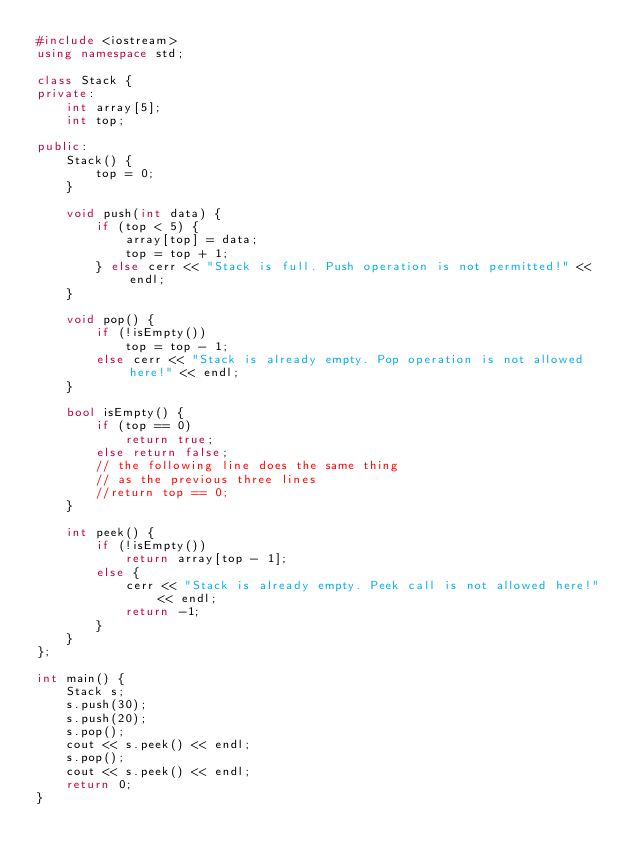<code> <loc_0><loc_0><loc_500><loc_500><_C++_>#include <iostream>
using namespace std;

class Stack {
private:
    int array[5];
    int top;

public:
    Stack() {
        top = 0;
    }

    void push(int data) {
        if (top < 5) {
            array[top] = data;
            top = top + 1;
        } else cerr << "Stack is full. Push operation is not permitted!" << endl;
    }

    void pop() {
        if (!isEmpty())
            top = top - 1;
        else cerr << "Stack is already empty. Pop operation is not allowed here!" << endl;
    }

    bool isEmpty() {
        if (top == 0)
            return true;
        else return false;
        // the following line does the same thing
        // as the previous three lines
        //return top == 0;
    }

    int peek() {
        if (!isEmpty())
            return array[top - 1];
        else {
            cerr << "Stack is already empty. Peek call is not allowed here!" << endl;
            return -1;
        }
    }
};

int main() {
    Stack s;
    s.push(30);
    s.push(20);
    s.pop();
    cout << s.peek() << endl;
    s.pop();
    cout << s.peek() << endl;
    return 0;
}
</code> 